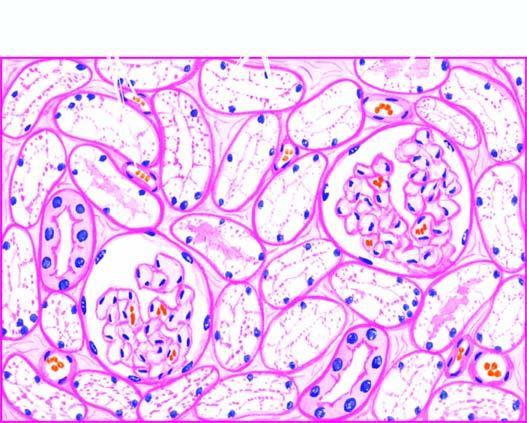re the nuclei of affected tubules pale?
Answer the question using a single word or phrase. Yes 